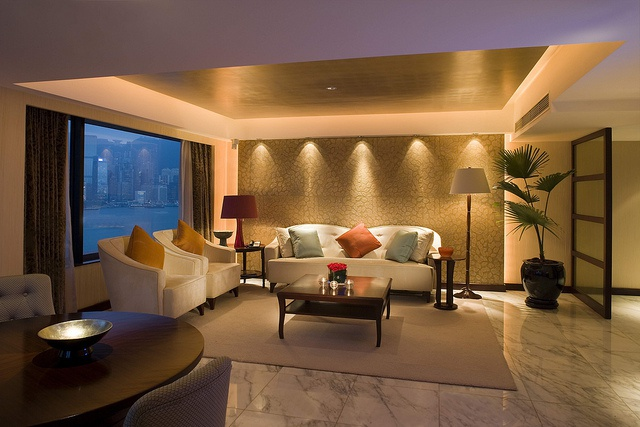Describe the objects in this image and their specific colors. I can see dining table in black, maroon, and navy tones, couch in black, tan, olive, and brown tones, chair in black, brown, maroon, and tan tones, potted plant in black and olive tones, and couch in black, brown, maroon, and tan tones in this image. 